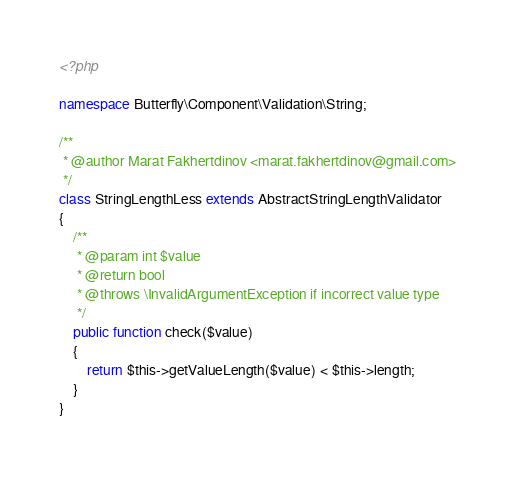Convert code to text. <code><loc_0><loc_0><loc_500><loc_500><_PHP_><?php

namespace Butterfly\Component\Validation\String;

/**
 * @author Marat Fakhertdinov <marat.fakhertdinov@gmail.com>
 */
class StringLengthLess extends AbstractStringLengthValidator
{
    /**
     * @param int $value
     * @return bool
     * @throws \InvalidArgumentException if incorrect value type
     */
    public function check($value)
    {
        return $this->getValueLength($value) < $this->length;
    }
}
</code> 